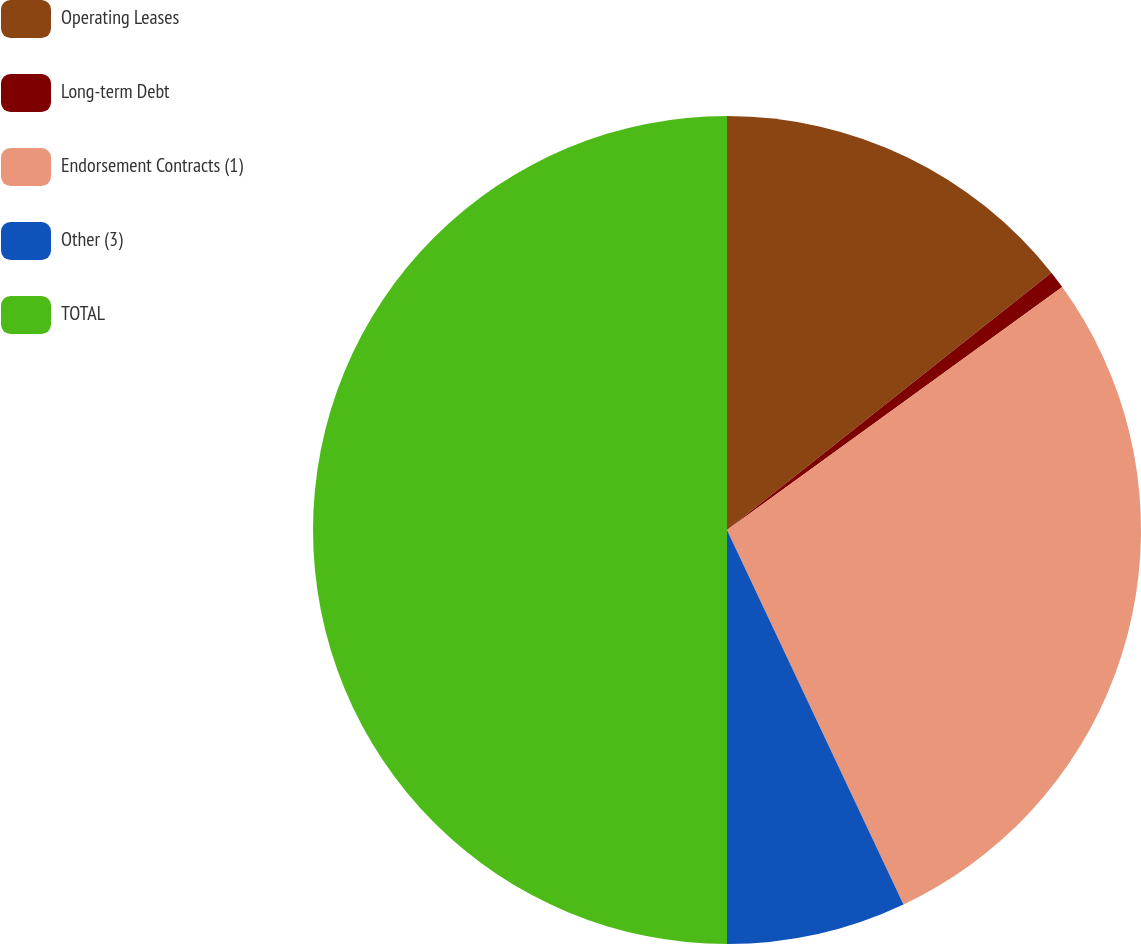<chart> <loc_0><loc_0><loc_500><loc_500><pie_chart><fcel>Operating Leases<fcel>Long-term Debt<fcel>Endorsement Contracts (1)<fcel>Other (3)<fcel>TOTAL<nl><fcel>14.33%<fcel>0.69%<fcel>27.97%<fcel>7.01%<fcel>50.0%<nl></chart> 